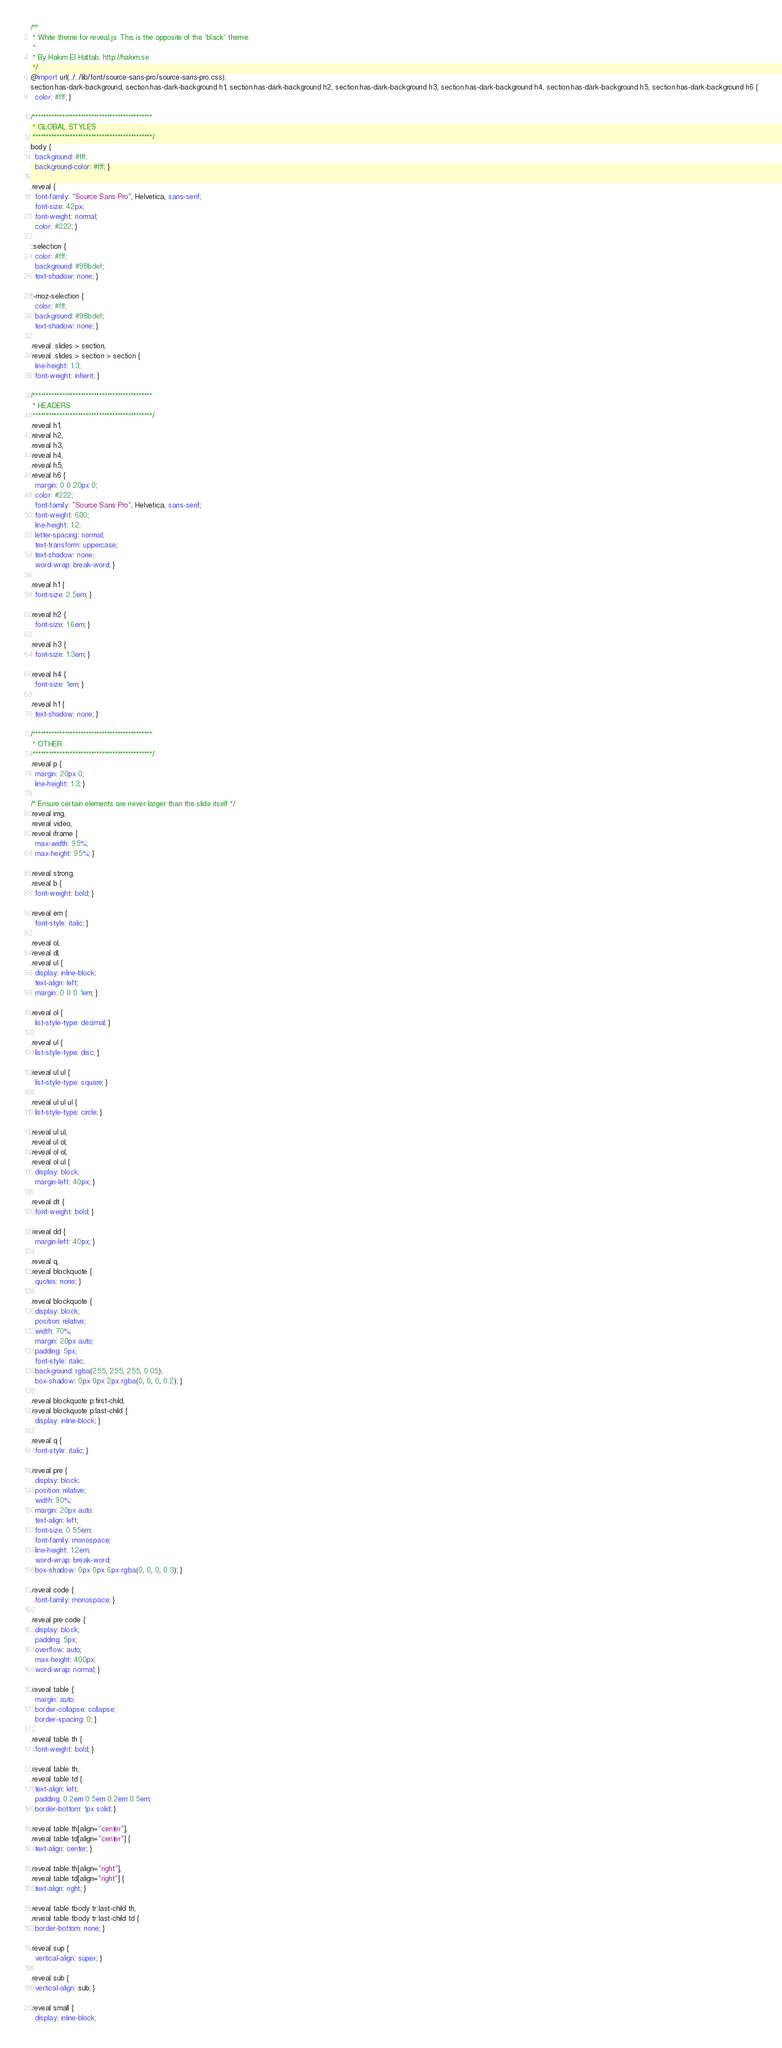Convert code to text. <code><loc_0><loc_0><loc_500><loc_500><_CSS_>/**
 * White theme for reveal.js. This is the opposite of the 'black' theme.
 *
 * By Hakim El Hattab, http://hakim.se
 */
@import url(../../lib/font/source-sans-pro/source-sans-pro.css);
section.has-dark-background, section.has-dark-background h1, section.has-dark-background h2, section.has-dark-background h3, section.has-dark-background h4, section.has-dark-background h5, section.has-dark-background h6 {
  color: #fff; }

/*********************************************
 * GLOBAL STYLES
 *********************************************/
body {
  background: #fff;
  background-color: #fff; }

.reveal {
  font-family: "Source Sans Pro", Helvetica, sans-serif;
  font-size: 42px;
  font-weight: normal;
  color: #222; }

::selection {
  color: #fff;
  background: #98bdef;
  text-shadow: none; }

::-moz-selection {
  color: #fff;
  background: #98bdef;
  text-shadow: none; }

.reveal .slides > section,
.reveal .slides > section > section {
  line-height: 1.3;
  font-weight: inherit; }

/*********************************************
 * HEADERS
 *********************************************/
.reveal h1,
.reveal h2,
.reveal h3,
.reveal h4,
.reveal h5,
.reveal h6 {
  margin: 0 0 20px 0;
  color: #222;
  font-family: "Source Sans Pro", Helvetica, sans-serif;
  font-weight: 600;
  line-height: 1.2;
  letter-spacing: normal;
  text-transform: uppercase;
  text-shadow: none;
  word-wrap: break-word; }

.reveal h1 {
  font-size: 2.5em; }

.reveal h2 {
  font-size: 1.6em; }

.reveal h3 {
  font-size: 1.3em; }

.reveal h4 {
  font-size: 1em; }

.reveal h1 {
  text-shadow: none; }

/*********************************************
 * OTHER
 *********************************************/
.reveal p {
  margin: 20px 0;
  line-height: 1.3; }

/* Ensure certain elements are never larger than the slide itself */
.reveal img,
.reveal video,
.reveal iframe {
  max-width: 95%;
  max-height: 95%; }

.reveal strong,
.reveal b {
  font-weight: bold; }

.reveal em {
  font-style: italic; }

.reveal ol,
.reveal dl,
.reveal ul {
  display: inline-block;
  text-align: left;
  margin: 0 0 0 1em; }

.reveal ol {
  list-style-type: decimal; }

.reveal ul {
  list-style-type: disc; }

.reveal ul ul {
  list-style-type: square; }

.reveal ul ul ul {
  list-style-type: circle; }

.reveal ul ul,
.reveal ul ol,
.reveal ol ol,
.reveal ol ul {
  display: block;
  margin-left: 40px; }

.reveal dt {
  font-weight: bold; }

.reveal dd {
  margin-left: 40px; }

.reveal q,
.reveal blockquote {
  quotes: none; }

.reveal blockquote {
  display: block;
  position: relative;
  width: 70%;
  margin: 20px auto;
  padding: 5px;
  font-style: italic;
  background: rgba(255, 255, 255, 0.05);
  box-shadow: 0px 0px 2px rgba(0, 0, 0, 0.2); }

.reveal blockquote p:first-child,
.reveal blockquote p:last-child {
  display: inline-block; }

.reveal q {
  font-style: italic; }

.reveal pre {
  display: block;
  position: relative;
  width: 90%;
  margin: 20px auto;
  text-align: left;
  font-size: 0.55em;
  font-family: monospace;
  line-height: 1.2em;
  word-wrap: break-word;
  box-shadow: 0px 0px 6px rgba(0, 0, 0, 0.3); }

.reveal code {
  font-family: monospace; }

.reveal pre code {
  display: block;
  padding: 5px;
  overflow: auto;
  max-height: 400px;
  word-wrap: normal; }

.reveal table {
  margin: auto;
  border-collapse: collapse;
  border-spacing: 0; }

.reveal table th {
  font-weight: bold; }

.reveal table th,
.reveal table td {
  text-align: left;
  padding: 0.2em 0.5em 0.2em 0.5em;
  border-bottom: 1px solid; }

.reveal table th[align="center"],
.reveal table td[align="center"] {
  text-align: center; }

.reveal table th[align="right"],
.reveal table td[align="right"] {
  text-align: right; }

.reveal table tbody tr:last-child th,
.reveal table tbody tr:last-child td {
  border-bottom: none; }

.reveal sup {
  vertical-align: super; }

.reveal sub {
  vertical-align: sub; }

.reveal small {
  display: inline-block;</code> 